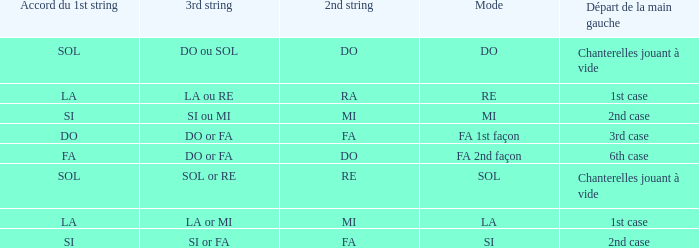For the 2nd string of Do and an Accord du 1st string of FA what is the Depart de la main gauche? 6th case. 